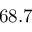<formula> <loc_0><loc_0><loc_500><loc_500>6 8 . 7</formula> 